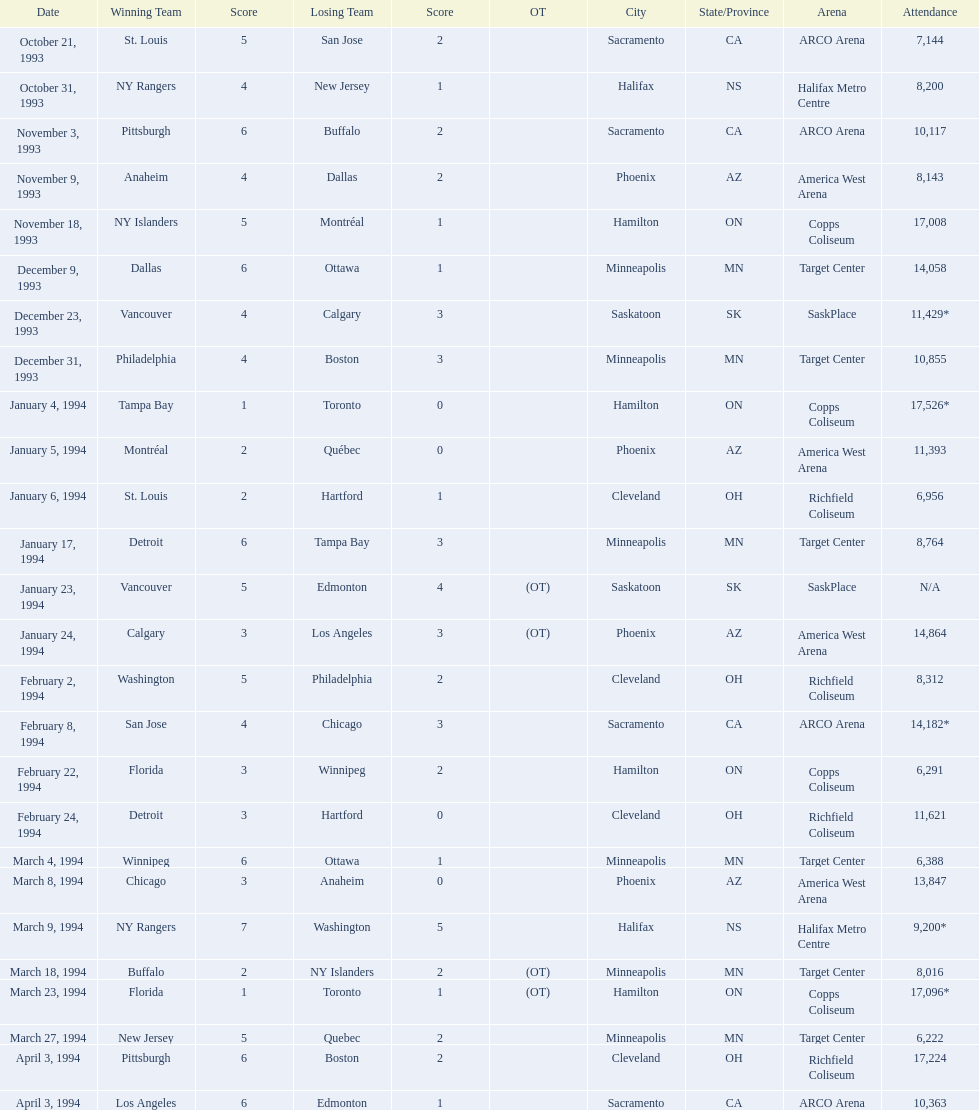What was the attendance on january 24, 1994? 14,864. What was the attendance on december 23, 1993? 11,429*. Between january 24, 1994 and december 23, 1993, which had the higher attendance? January 4, 1994. 